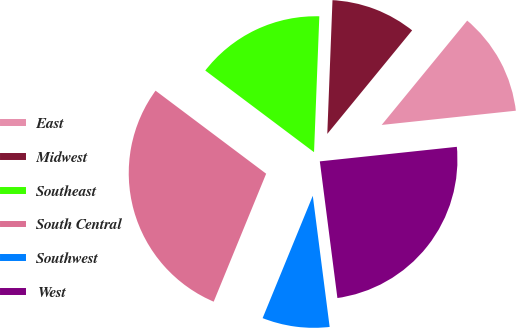<chart> <loc_0><loc_0><loc_500><loc_500><pie_chart><fcel>East<fcel>Midwest<fcel>Southeast<fcel>South Central<fcel>Southwest<fcel>West<nl><fcel>12.39%<fcel>10.31%<fcel>15.37%<fcel>29.06%<fcel>8.23%<fcel>24.65%<nl></chart> 